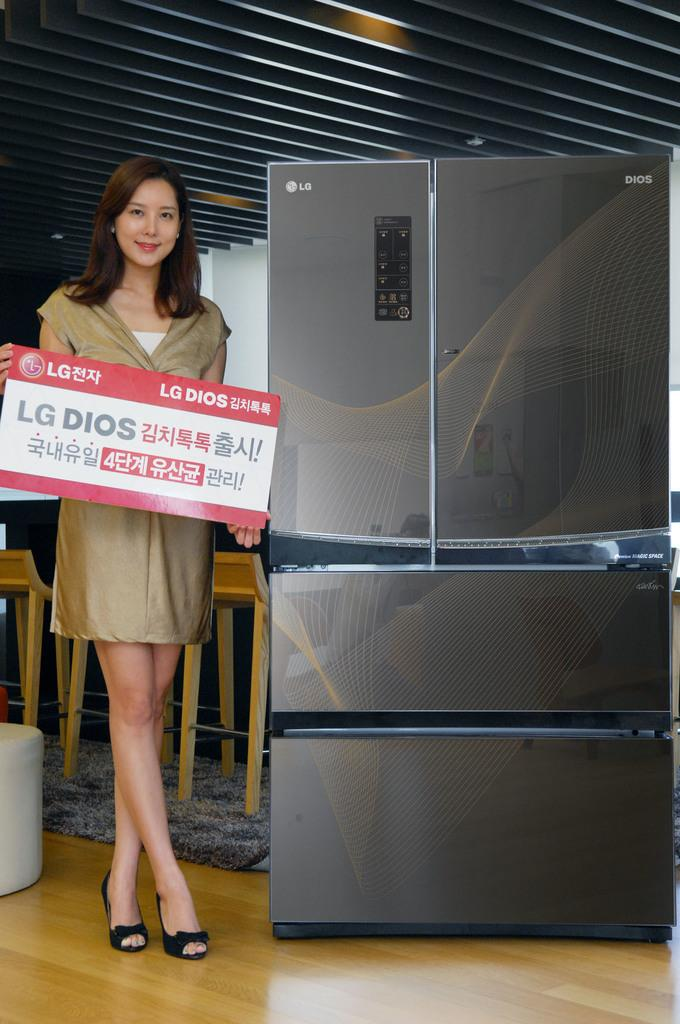Provide a one-sentence caption for the provided image. A woman standing next to a fridge with an LG logo. 